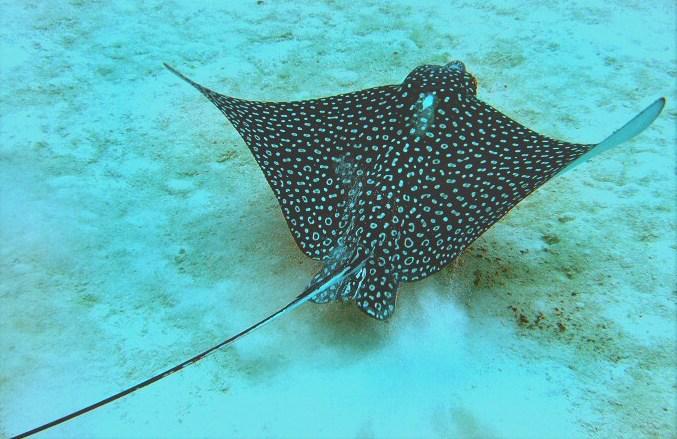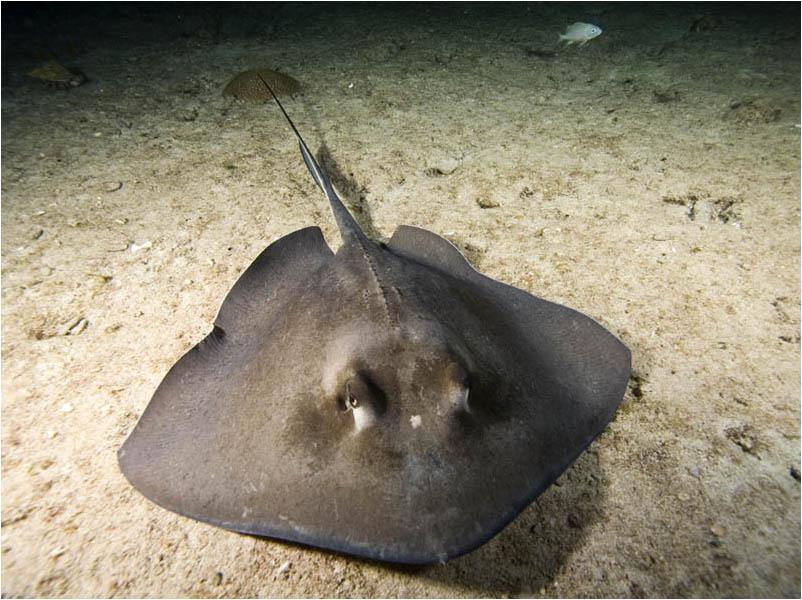The first image is the image on the left, the second image is the image on the right. For the images displayed, is the sentence "A single spotted ray is swimming directly away from the camera." factually correct? Answer yes or no. Yes. The first image is the image on the left, the second image is the image on the right. Examine the images to the left and right. Is the description "Right image shows one pale, almost white stingray." accurate? Answer yes or no. No. 